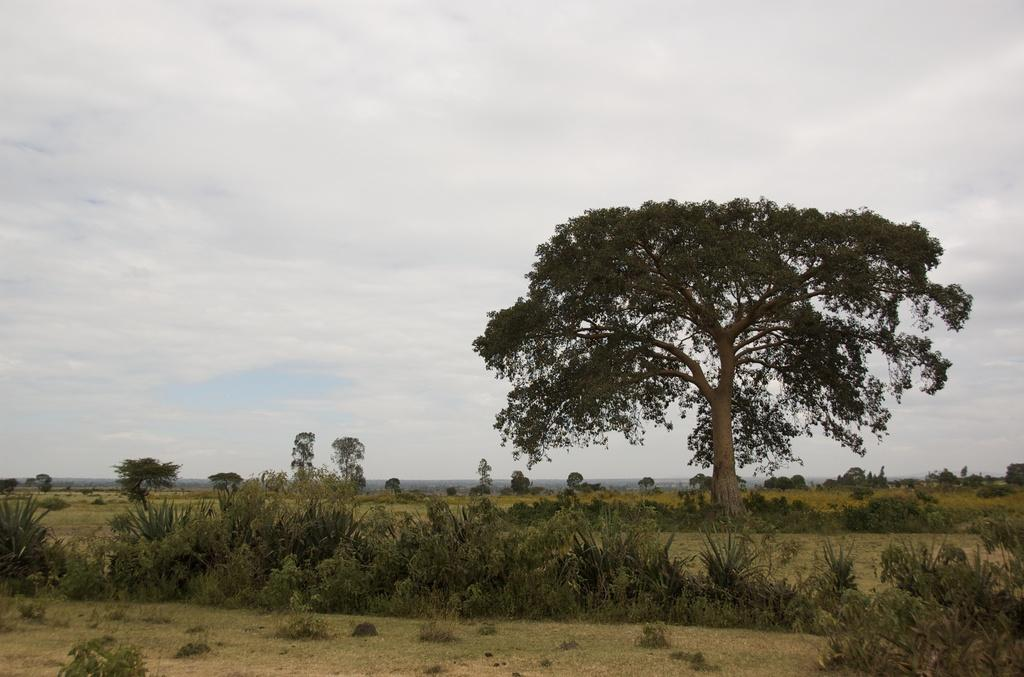What type of vegetation is at the bottom of the picture? There is grass and trees at the bottom of the picture. What else can be seen at the bottom of the picture? There are trees at the bottom of the picture. What is visible in the background of the picture? There are trees and hills in the background of the picture. What is the main feature in the middle of the picture? There is a big tree in the middle of the picture. What is visible at the top of the picture? The sky is visible at the top of the picture. What type of rail can be seen in the picture? There is no rail present in the picture. What kind of play equipment is visible in the picture? There is no play equipment visible in the picture. 